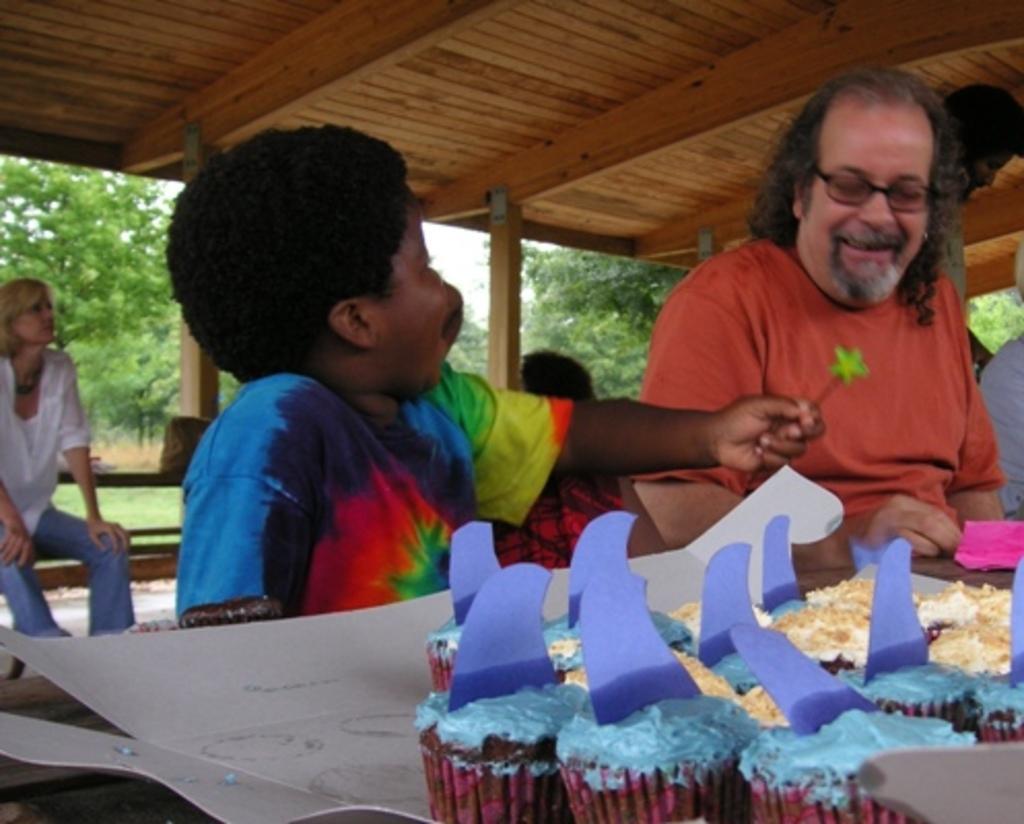Could you give a brief overview of what you see in this image? In this picture I can see few people sitting on the bench and I can see a boy holding something in his hand and I can see few muffins and trees in the back. 